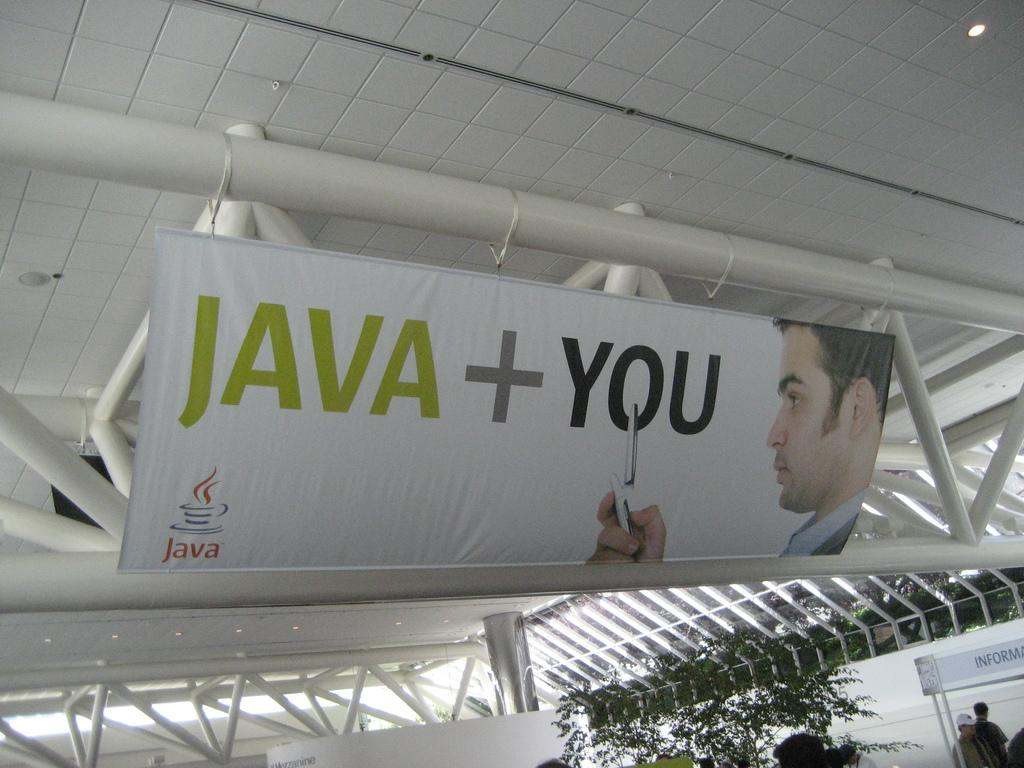<image>
Create a compact narrative representing the image presented. A simple white banner advertises for Java technology. 